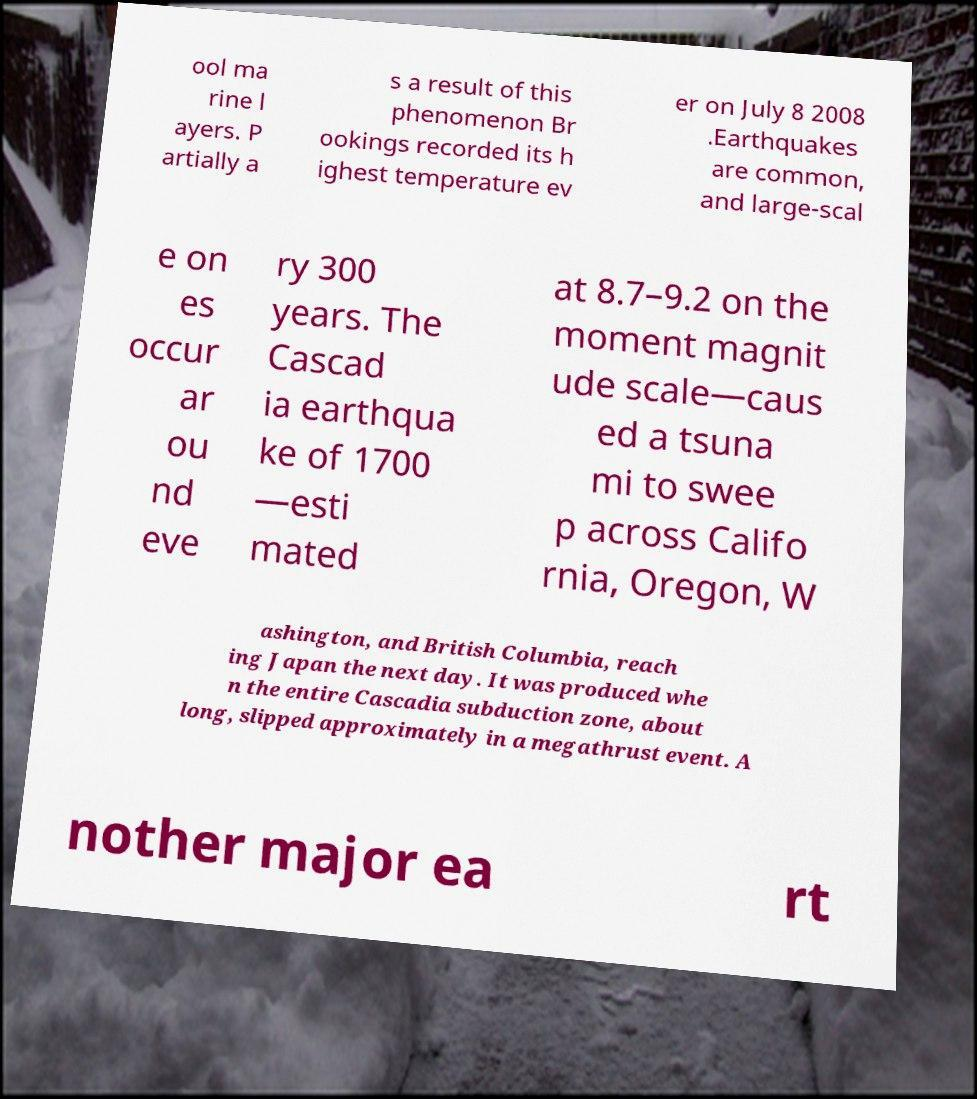Please identify and transcribe the text found in this image. ool ma rine l ayers. P artially a s a result of this phenomenon Br ookings recorded its h ighest temperature ev er on July 8 2008 .Earthquakes are common, and large-scal e on es occur ar ou nd eve ry 300 years. The Cascad ia earthqua ke of 1700 —esti mated at 8.7–9.2 on the moment magnit ude scale—caus ed a tsuna mi to swee p across Califo rnia, Oregon, W ashington, and British Columbia, reach ing Japan the next day. It was produced whe n the entire Cascadia subduction zone, about long, slipped approximately in a megathrust event. A nother major ea rt 